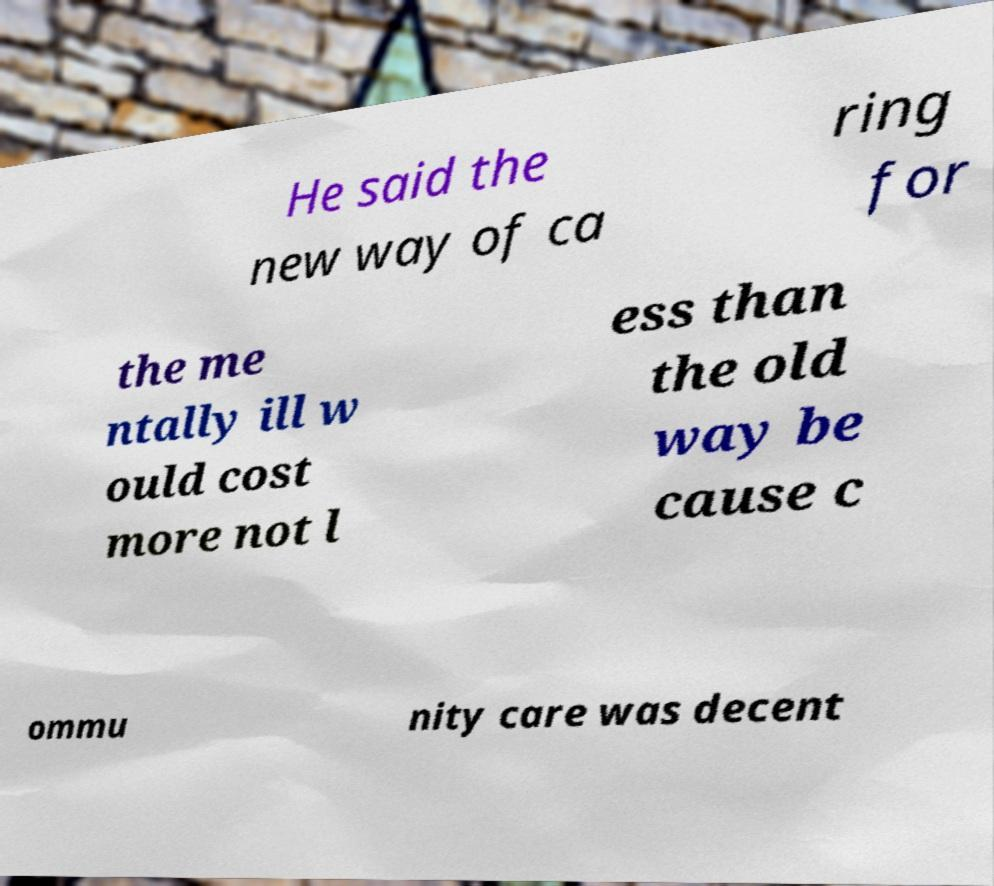Please identify and transcribe the text found in this image. He said the new way of ca ring for the me ntally ill w ould cost more not l ess than the old way be cause c ommu nity care was decent 